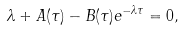<formula> <loc_0><loc_0><loc_500><loc_500>\lambda + A ( \tau ) - B ( \tau ) e ^ { - \lambda \tau } = 0 ,</formula> 